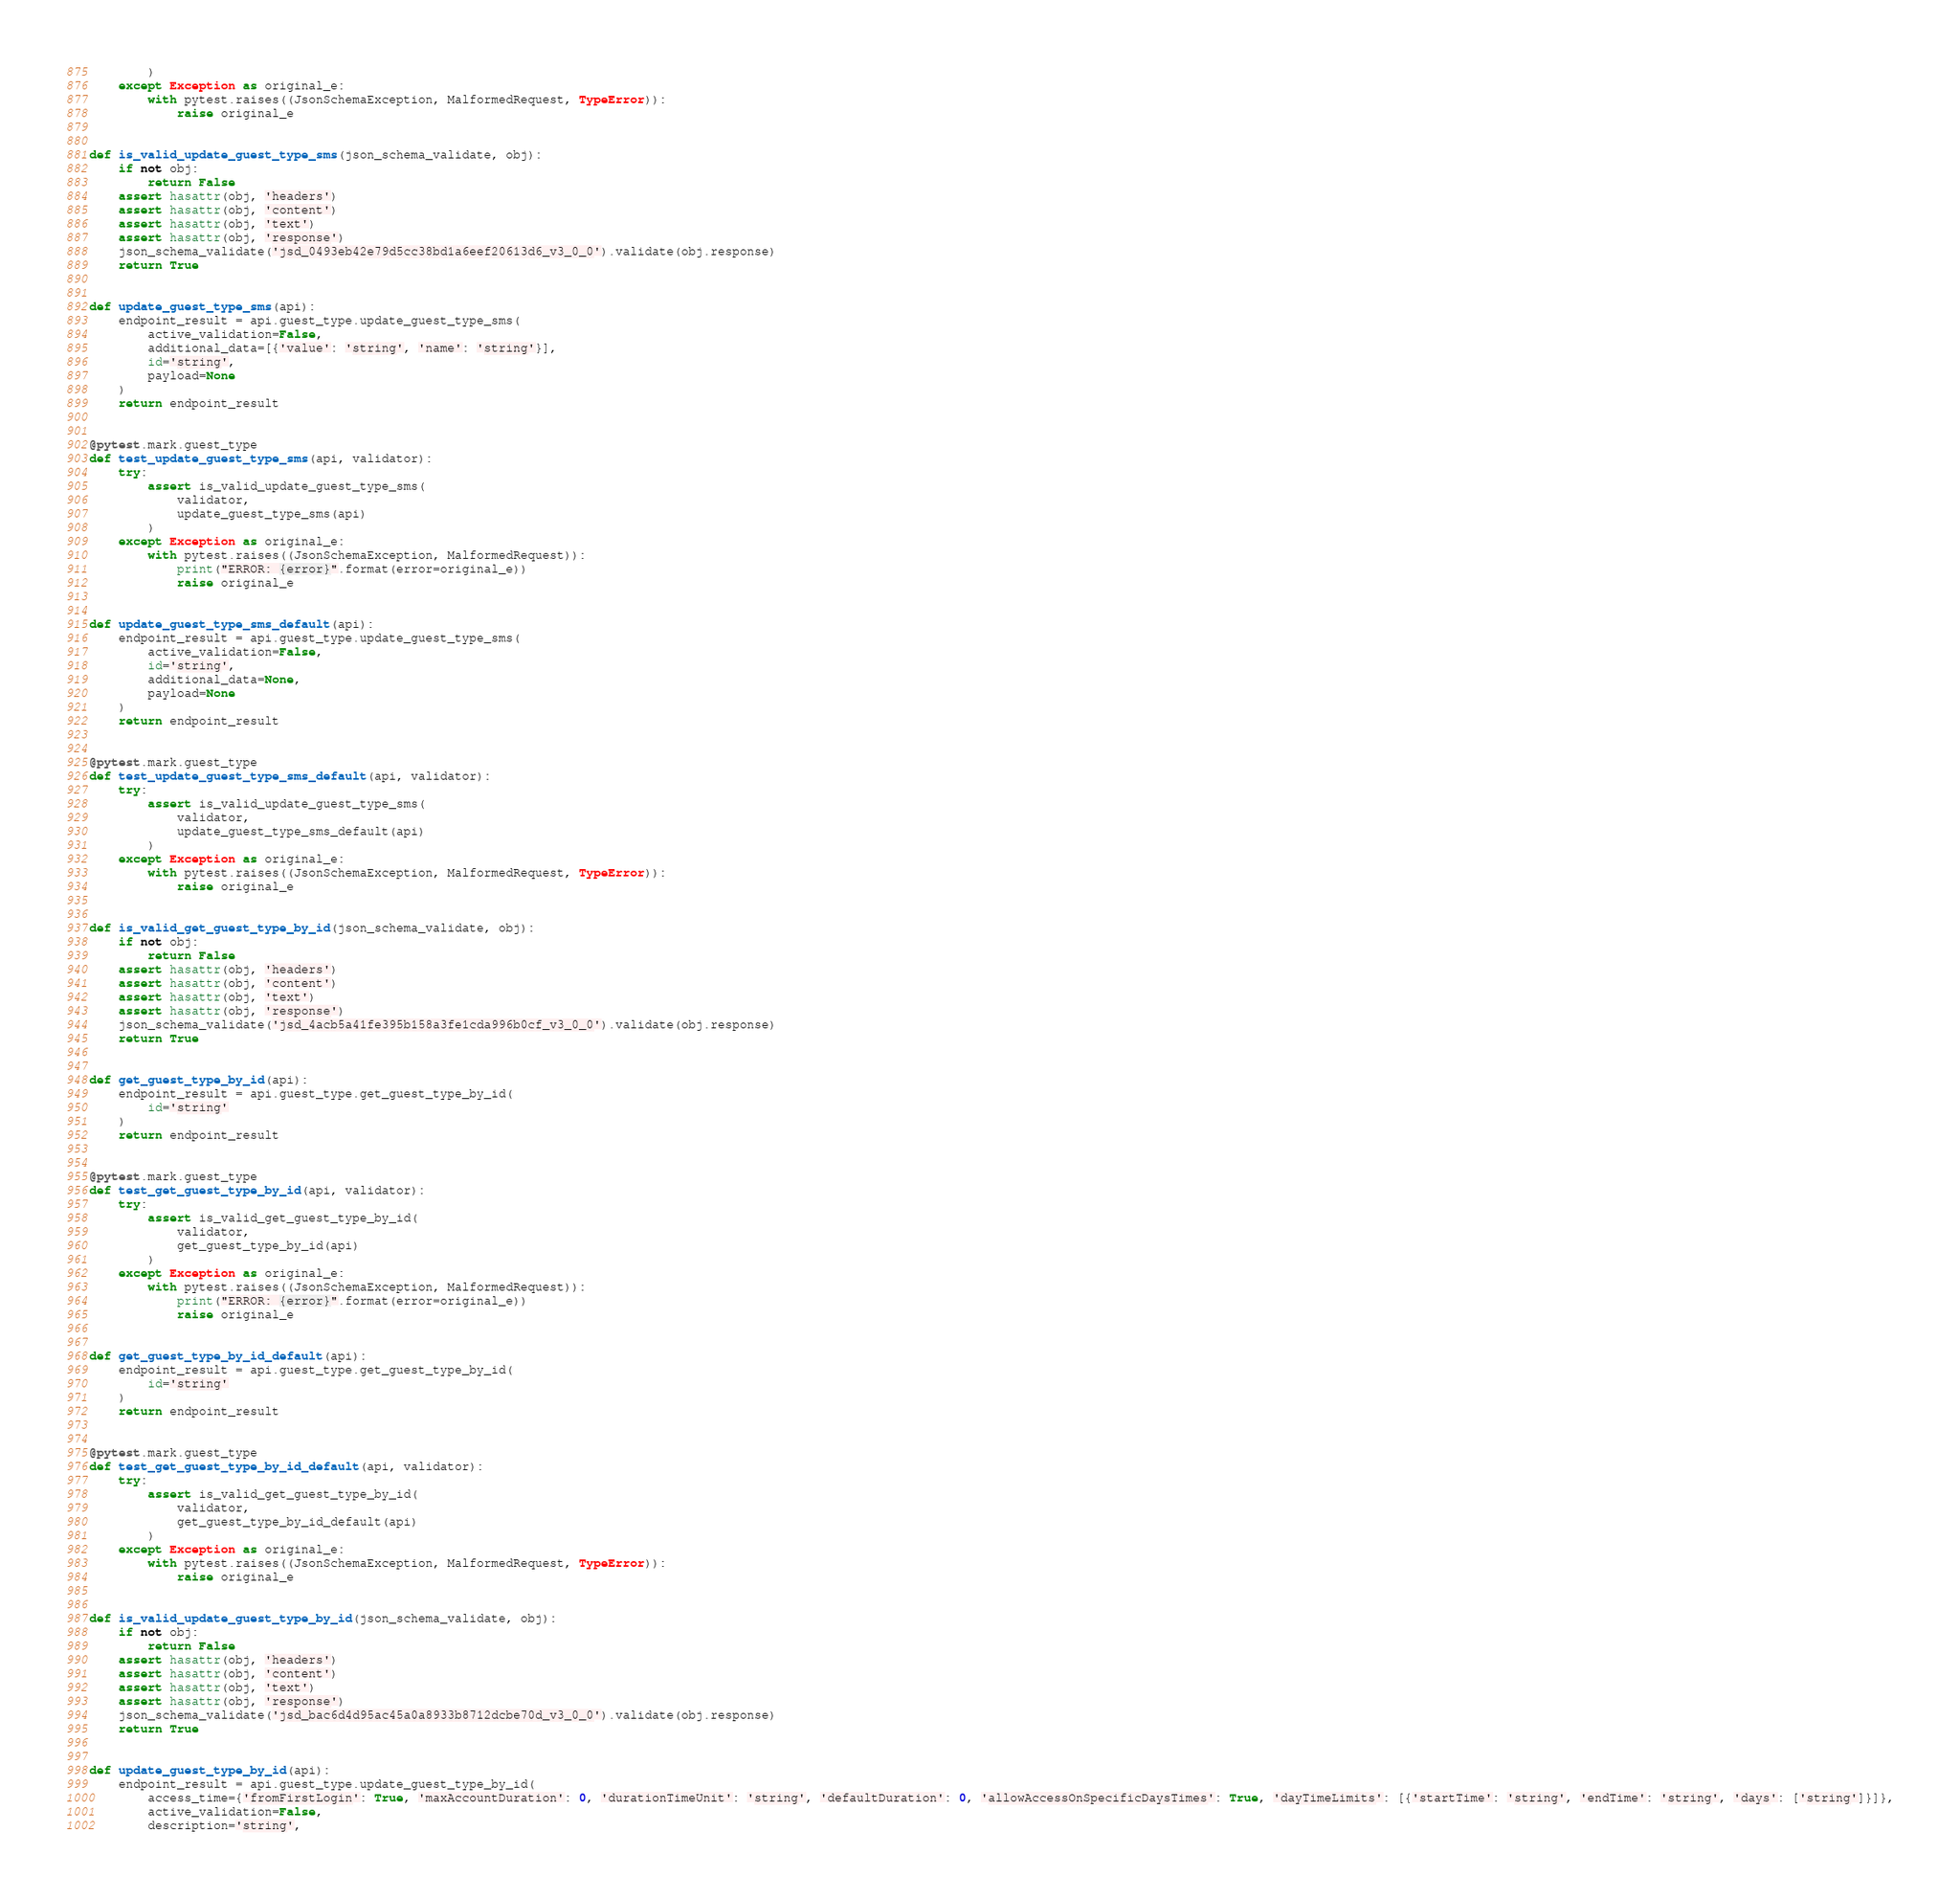<code> <loc_0><loc_0><loc_500><loc_500><_Python_>        )
    except Exception as original_e:
        with pytest.raises((JsonSchemaException, MalformedRequest, TypeError)):
            raise original_e


def is_valid_update_guest_type_sms(json_schema_validate, obj):
    if not obj:
        return False
    assert hasattr(obj, 'headers')
    assert hasattr(obj, 'content')
    assert hasattr(obj, 'text')
    assert hasattr(obj, 'response')
    json_schema_validate('jsd_0493eb42e79d5cc38bd1a6eef20613d6_v3_0_0').validate(obj.response)
    return True


def update_guest_type_sms(api):
    endpoint_result = api.guest_type.update_guest_type_sms(
        active_validation=False,
        additional_data=[{'value': 'string', 'name': 'string'}],
        id='string',
        payload=None
    )
    return endpoint_result


@pytest.mark.guest_type
def test_update_guest_type_sms(api, validator):
    try:
        assert is_valid_update_guest_type_sms(
            validator,
            update_guest_type_sms(api)
        )
    except Exception as original_e:
        with pytest.raises((JsonSchemaException, MalformedRequest)):
            print("ERROR: {error}".format(error=original_e))
            raise original_e


def update_guest_type_sms_default(api):
    endpoint_result = api.guest_type.update_guest_type_sms(
        active_validation=False,
        id='string',
        additional_data=None,
        payload=None
    )
    return endpoint_result


@pytest.mark.guest_type
def test_update_guest_type_sms_default(api, validator):
    try:
        assert is_valid_update_guest_type_sms(
            validator,
            update_guest_type_sms_default(api)
        )
    except Exception as original_e:
        with pytest.raises((JsonSchemaException, MalformedRequest, TypeError)):
            raise original_e


def is_valid_get_guest_type_by_id(json_schema_validate, obj):
    if not obj:
        return False
    assert hasattr(obj, 'headers')
    assert hasattr(obj, 'content')
    assert hasattr(obj, 'text')
    assert hasattr(obj, 'response')
    json_schema_validate('jsd_4acb5a41fe395b158a3fe1cda996b0cf_v3_0_0').validate(obj.response)
    return True


def get_guest_type_by_id(api):
    endpoint_result = api.guest_type.get_guest_type_by_id(
        id='string'
    )
    return endpoint_result


@pytest.mark.guest_type
def test_get_guest_type_by_id(api, validator):
    try:
        assert is_valid_get_guest_type_by_id(
            validator,
            get_guest_type_by_id(api)
        )
    except Exception as original_e:
        with pytest.raises((JsonSchemaException, MalformedRequest)):
            print("ERROR: {error}".format(error=original_e))
            raise original_e


def get_guest_type_by_id_default(api):
    endpoint_result = api.guest_type.get_guest_type_by_id(
        id='string'
    )
    return endpoint_result


@pytest.mark.guest_type
def test_get_guest_type_by_id_default(api, validator):
    try:
        assert is_valid_get_guest_type_by_id(
            validator,
            get_guest_type_by_id_default(api)
        )
    except Exception as original_e:
        with pytest.raises((JsonSchemaException, MalformedRequest, TypeError)):
            raise original_e


def is_valid_update_guest_type_by_id(json_schema_validate, obj):
    if not obj:
        return False
    assert hasattr(obj, 'headers')
    assert hasattr(obj, 'content')
    assert hasattr(obj, 'text')
    assert hasattr(obj, 'response')
    json_schema_validate('jsd_bac6d4d95ac45a0a8933b8712dcbe70d_v3_0_0').validate(obj.response)
    return True


def update_guest_type_by_id(api):
    endpoint_result = api.guest_type.update_guest_type_by_id(
        access_time={'fromFirstLogin': True, 'maxAccountDuration': 0, 'durationTimeUnit': 'string', 'defaultDuration': 0, 'allowAccessOnSpecificDaysTimes': True, 'dayTimeLimits': [{'startTime': 'string', 'endTime': 'string', 'days': ['string']}]},
        active_validation=False,
        description='string',</code> 